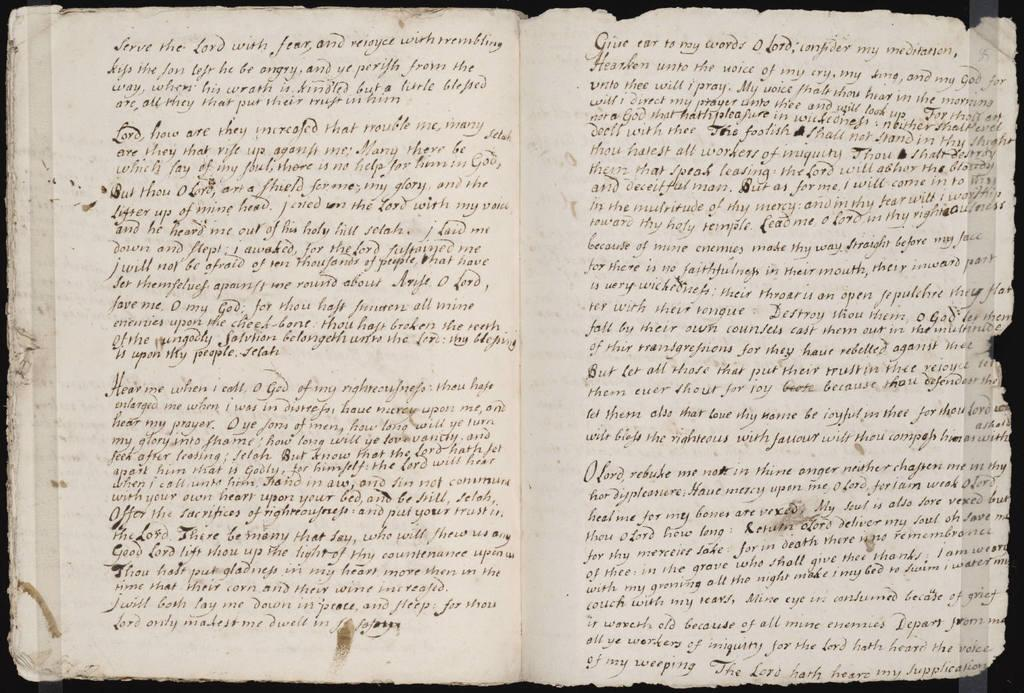What is present in the picture? There is a book in the picture. What is the state of the book in the image? The book is opened. What can be seen inside the book? There is information visible in the book. What type of society is depicted in the book? There is no society depicted in the book, as it is not a visual representation of a society. 